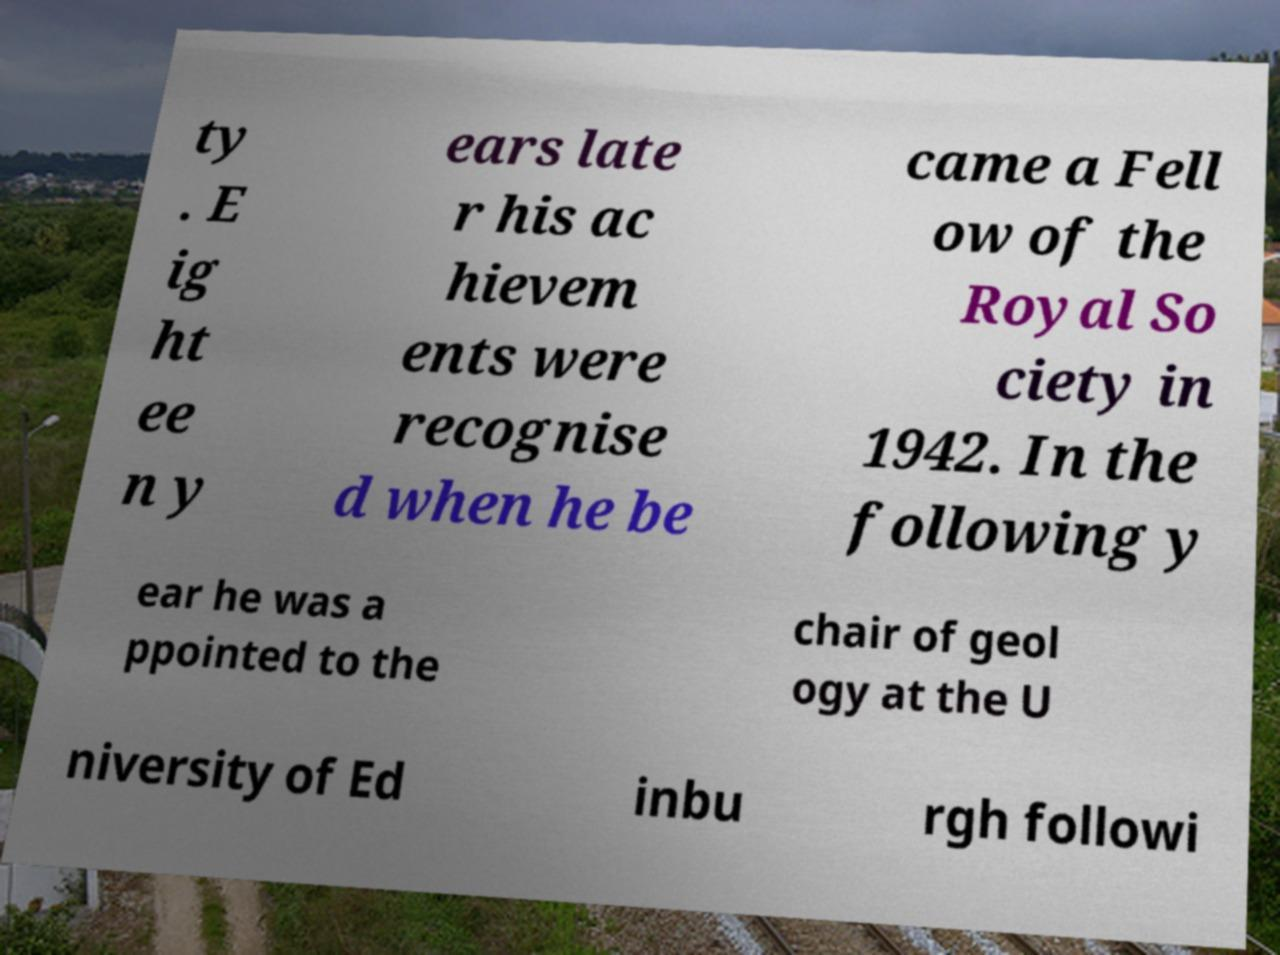For documentation purposes, I need the text within this image transcribed. Could you provide that? ty . E ig ht ee n y ears late r his ac hievem ents were recognise d when he be came a Fell ow of the Royal So ciety in 1942. In the following y ear he was a ppointed to the chair of geol ogy at the U niversity of Ed inbu rgh followi 